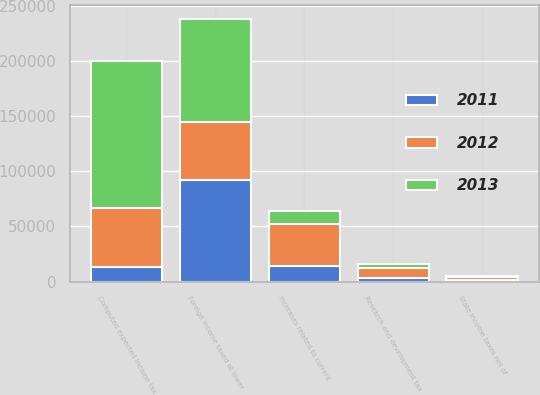<chart> <loc_0><loc_0><loc_500><loc_500><stacked_bar_chart><ecel><fcel>Computed expected income tax<fcel>State income taxes net of<fcel>Research and development tax<fcel>Foreign income taxed at lower<fcel>Increases related to current<nl><fcel>2012<fcel>53262<fcel>2054<fcel>8263<fcel>52317<fcel>37507<nl><fcel>2013<fcel>132894<fcel>1280<fcel>3750<fcel>93905<fcel>12365<nl><fcel>2011<fcel>13347.5<fcel>1746<fcel>3691<fcel>92166<fcel>14330<nl></chart> 